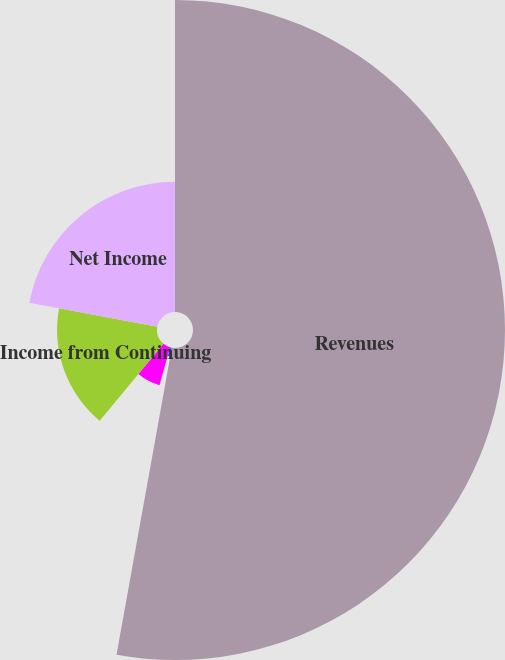Convert chart. <chart><loc_0><loc_0><loc_500><loc_500><pie_chart><fcel>Revenues<fcel>Income (Loss) from Continuing<fcel>Net Income (Loss)<fcel>Income from Continuing<fcel>Net Income<nl><fcel>52.83%<fcel>1.53%<fcel>6.66%<fcel>16.92%<fcel>22.05%<nl></chart> 